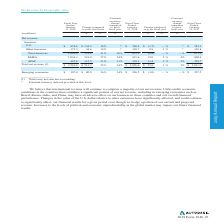According to Autodesk's financial document, What are some of the marketing expenses incurred by the company? Based on the financial document, the answer is salaries, bonuses, benefits and stock-based compensation expense for our marketing and sales employees, the expense of travel, entertainment and training for such personnel, sales and dealer commissions, and the costs of programs aimed at increasing revenue, such as advertising, trade shows and expositions, and various sales and promotional programs.. Also, What are some factors affecting cost of revenue in the near term? Based on the financial document, the answer is the volume and mix of product sales, fluctuations in consulting costs, amortization of developed technology, new customer support offerings, royalty rates for licensed technology embedded in our products and employee stock-based compensation expense. Also, can you calculate: What is the total cost of revenue and operating expenses for fiscal year ended January 31, 2019? Based on the calculation: 285.9 + 2,308.9 , the result is 2594.8 (in millions). The key data points involved are: 2,308.9, 285.9. Also, can you calculate: How much do the top two expense categories in 2018 add up to?  Based on the calculation: 1,087.3 + 755.5, the result is 1842.8 (in millions). The key data points involved are: 1,087.3, 755.5. Also, can you calculate: How much does amortization of developed technology account for total cost of revenue in 2018? Based on the calculation: 15.5/285.9 , the result is 5.42 (percentage). This is based on the information: "218.9 27% 24% 815.4 15.0 2 % 4% 800.4 APAC 485.6 115.5 31% 31% 370.1 11.4 3 % 2% 358.7 Total net revenue (1) $ 2,569.8 $ 513.2 25% 24% $ 2,056.6 $ 25.6 1 %..." The key data points involved are: 15.5, 285.9. Also, What is the total cost of revenue for 2019? Based on the financial document, the answer is 2,308.9 (in millions). 